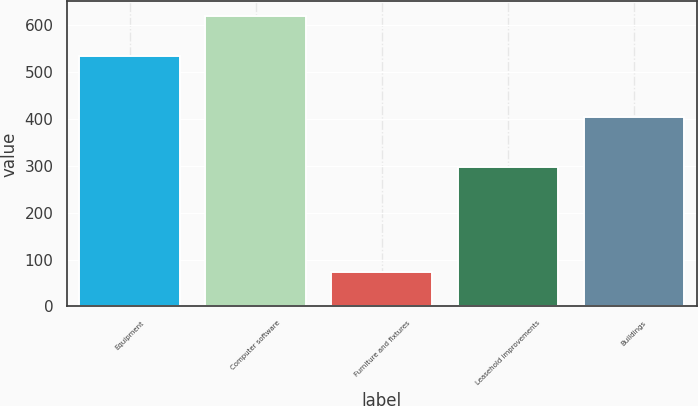Convert chart to OTSL. <chart><loc_0><loc_0><loc_500><loc_500><bar_chart><fcel>Equipment<fcel>Computer software<fcel>Furniture and fixtures<fcel>Leasehold improvements<fcel>Buildings<nl><fcel>533<fcel>619<fcel>73<fcel>296<fcel>403<nl></chart> 